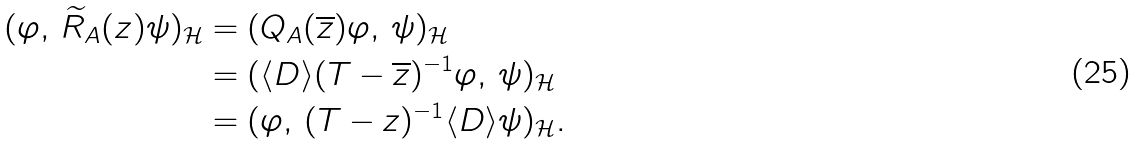Convert formula to latex. <formula><loc_0><loc_0><loc_500><loc_500>( \varphi , \, \widetilde { R } _ { A } ( z ) \psi ) _ { \mathcal { H } } & = ( Q _ { A } ( \overline { z } ) \varphi , \, \psi ) _ { \mathcal { H } } \\ & = ( \langle D \rangle ( T - { \overline { z } } ) ^ { - 1 } \varphi , \, \psi ) _ { \mathcal { H } } \\ & = ( \varphi , \, ( T - z ) ^ { - 1 } \langle D \rangle \psi ) _ { \mathcal { H } } .</formula> 